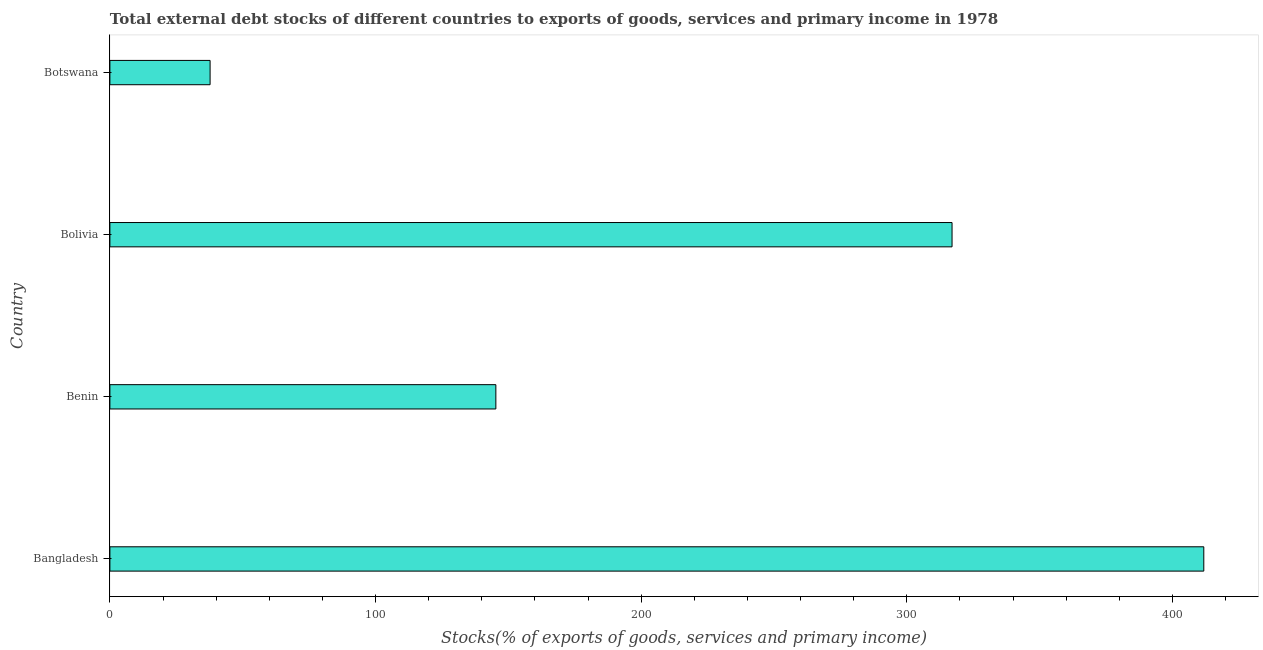Does the graph contain any zero values?
Offer a very short reply. No. Does the graph contain grids?
Your answer should be very brief. No. What is the title of the graph?
Your answer should be very brief. Total external debt stocks of different countries to exports of goods, services and primary income in 1978. What is the label or title of the X-axis?
Your answer should be compact. Stocks(% of exports of goods, services and primary income). What is the label or title of the Y-axis?
Keep it short and to the point. Country. What is the external debt stocks in Botswana?
Ensure brevity in your answer.  37.72. Across all countries, what is the maximum external debt stocks?
Your answer should be compact. 411.82. Across all countries, what is the minimum external debt stocks?
Your answer should be compact. 37.72. In which country was the external debt stocks minimum?
Provide a succinct answer. Botswana. What is the sum of the external debt stocks?
Give a very brief answer. 911.9. What is the difference between the external debt stocks in Benin and Botswana?
Your answer should be compact. 107.58. What is the average external debt stocks per country?
Keep it short and to the point. 227.97. What is the median external debt stocks?
Provide a succinct answer. 231.18. In how many countries, is the external debt stocks greater than 180 %?
Offer a very short reply. 2. What is the ratio of the external debt stocks in Bangladesh to that in Benin?
Your response must be concise. 2.83. Is the external debt stocks in Bangladesh less than that in Bolivia?
Ensure brevity in your answer.  No. What is the difference between the highest and the second highest external debt stocks?
Provide a succinct answer. 94.77. Is the sum of the external debt stocks in Bolivia and Botswana greater than the maximum external debt stocks across all countries?
Provide a succinct answer. No. What is the difference between the highest and the lowest external debt stocks?
Your answer should be very brief. 374.1. Are all the bars in the graph horizontal?
Your answer should be compact. Yes. How many countries are there in the graph?
Your answer should be compact. 4. What is the difference between two consecutive major ticks on the X-axis?
Provide a short and direct response. 100. Are the values on the major ticks of X-axis written in scientific E-notation?
Offer a very short reply. No. What is the Stocks(% of exports of goods, services and primary income) of Bangladesh?
Make the answer very short. 411.82. What is the Stocks(% of exports of goods, services and primary income) of Benin?
Your response must be concise. 145.3. What is the Stocks(% of exports of goods, services and primary income) of Bolivia?
Keep it short and to the point. 317.05. What is the Stocks(% of exports of goods, services and primary income) of Botswana?
Provide a succinct answer. 37.72. What is the difference between the Stocks(% of exports of goods, services and primary income) in Bangladesh and Benin?
Provide a succinct answer. 266.52. What is the difference between the Stocks(% of exports of goods, services and primary income) in Bangladesh and Bolivia?
Your response must be concise. 94.77. What is the difference between the Stocks(% of exports of goods, services and primary income) in Bangladesh and Botswana?
Make the answer very short. 374.1. What is the difference between the Stocks(% of exports of goods, services and primary income) in Benin and Bolivia?
Offer a terse response. -171.74. What is the difference between the Stocks(% of exports of goods, services and primary income) in Benin and Botswana?
Make the answer very short. 107.58. What is the difference between the Stocks(% of exports of goods, services and primary income) in Bolivia and Botswana?
Give a very brief answer. 279.32. What is the ratio of the Stocks(% of exports of goods, services and primary income) in Bangladesh to that in Benin?
Offer a very short reply. 2.83. What is the ratio of the Stocks(% of exports of goods, services and primary income) in Bangladesh to that in Bolivia?
Provide a short and direct response. 1.3. What is the ratio of the Stocks(% of exports of goods, services and primary income) in Bangladesh to that in Botswana?
Your response must be concise. 10.92. What is the ratio of the Stocks(% of exports of goods, services and primary income) in Benin to that in Bolivia?
Provide a succinct answer. 0.46. What is the ratio of the Stocks(% of exports of goods, services and primary income) in Benin to that in Botswana?
Your response must be concise. 3.85. What is the ratio of the Stocks(% of exports of goods, services and primary income) in Bolivia to that in Botswana?
Your answer should be very brief. 8.4. 